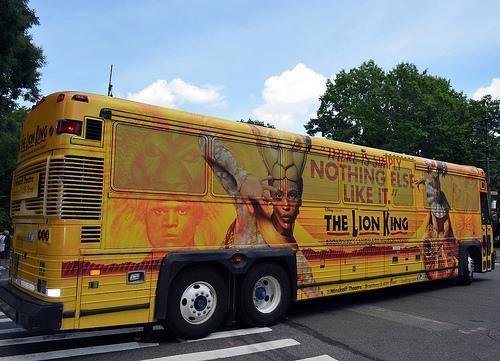How many buses are there?
Give a very brief answer. 1. 